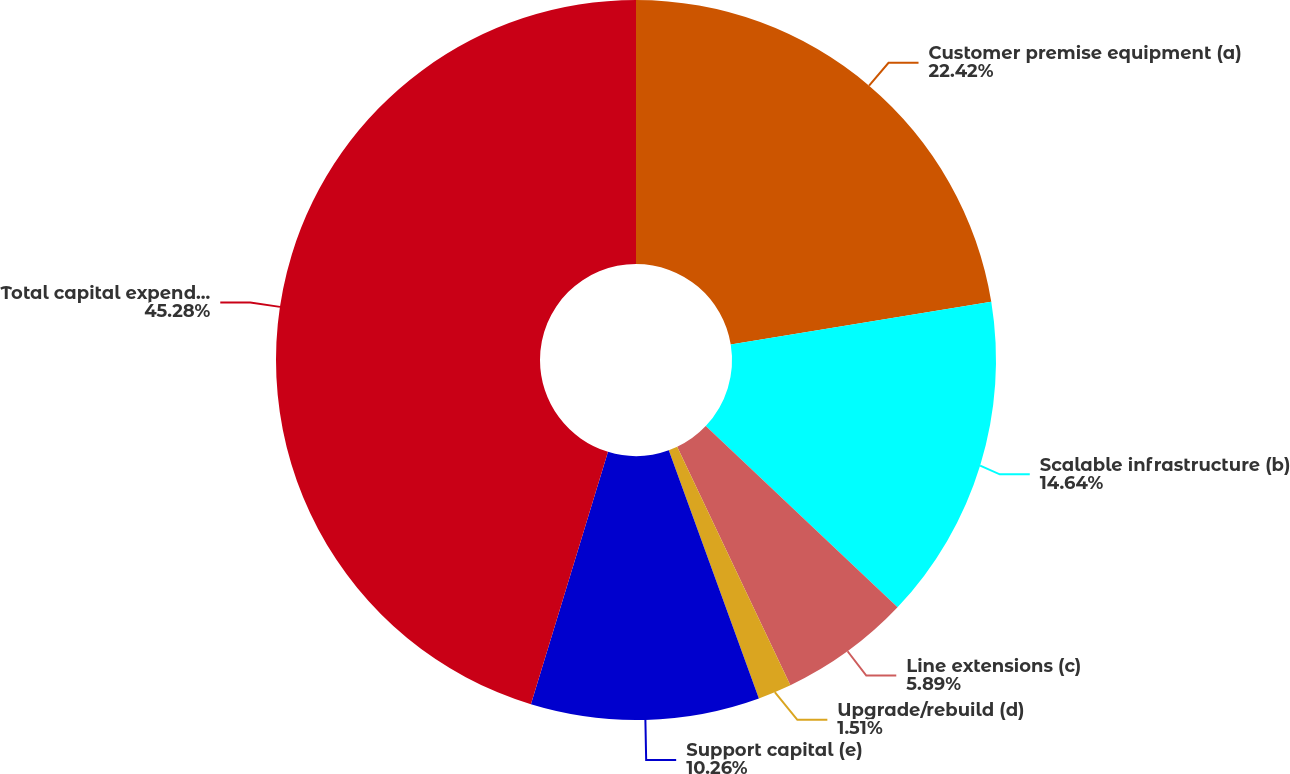Convert chart. <chart><loc_0><loc_0><loc_500><loc_500><pie_chart><fcel>Customer premise equipment (a)<fcel>Scalable infrastructure (b)<fcel>Line extensions (c)<fcel>Upgrade/rebuild (d)<fcel>Support capital (e)<fcel>Total capital expenditures (f)<nl><fcel>22.42%<fcel>14.64%<fcel>5.89%<fcel>1.51%<fcel>10.26%<fcel>45.29%<nl></chart> 